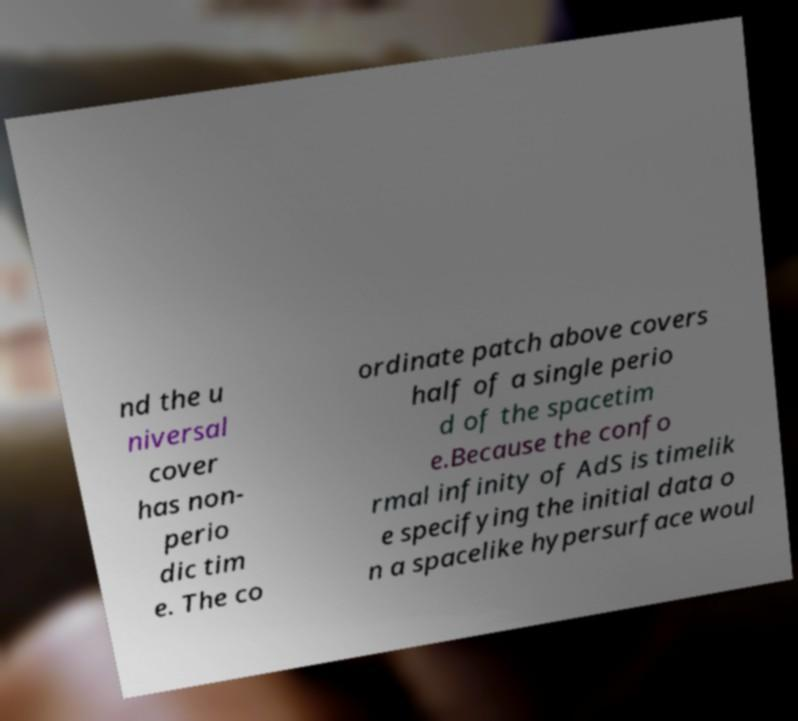Can you read and provide the text displayed in the image?This photo seems to have some interesting text. Can you extract and type it out for me? nd the u niversal cover has non- perio dic tim e. The co ordinate patch above covers half of a single perio d of the spacetim e.Because the confo rmal infinity of AdS is timelik e specifying the initial data o n a spacelike hypersurface woul 